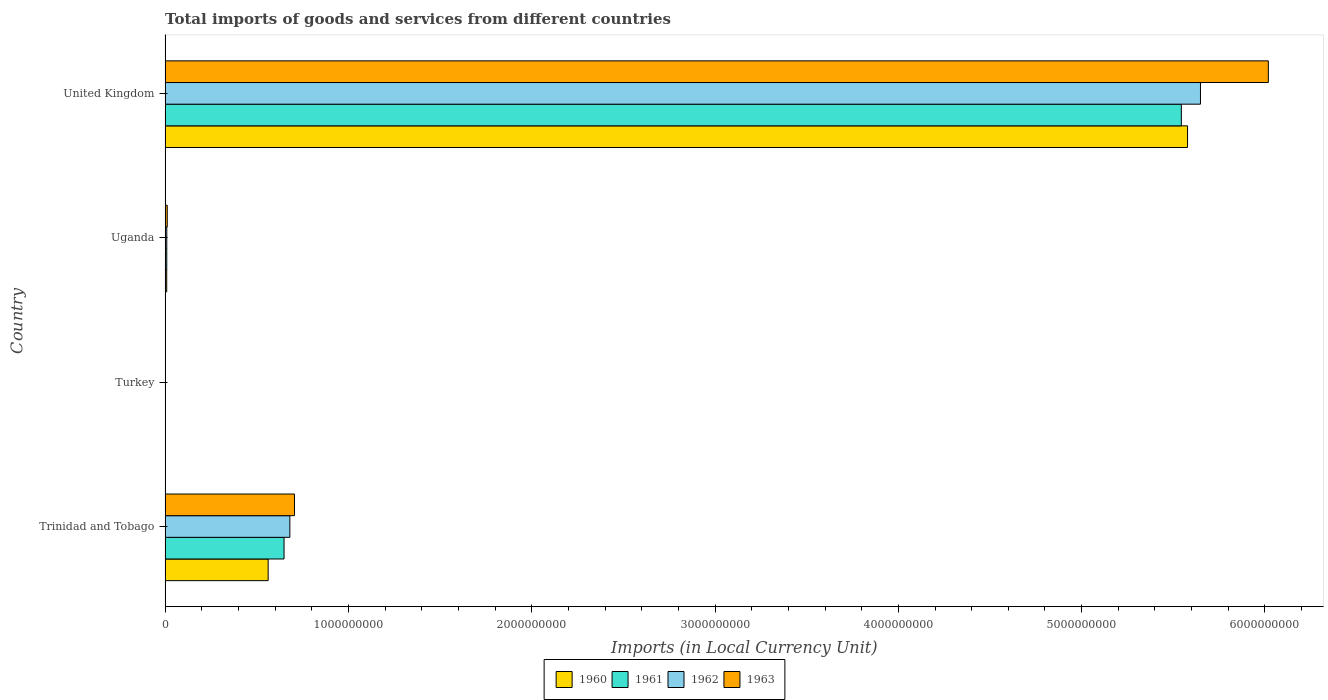How many different coloured bars are there?
Make the answer very short. 4. Are the number of bars per tick equal to the number of legend labels?
Give a very brief answer. Yes. Are the number of bars on each tick of the Y-axis equal?
Give a very brief answer. Yes. What is the label of the 2nd group of bars from the top?
Provide a short and direct response. Uganda. In how many cases, is the number of bars for a given country not equal to the number of legend labels?
Offer a very short reply. 0. What is the Amount of goods and services imports in 1962 in Trinidad and Tobago?
Your response must be concise. 6.81e+08. Across all countries, what is the maximum Amount of goods and services imports in 1960?
Your response must be concise. 5.58e+09. Across all countries, what is the minimum Amount of goods and services imports in 1962?
Offer a very short reply. 6400. In which country was the Amount of goods and services imports in 1961 maximum?
Your response must be concise. United Kingdom. In which country was the Amount of goods and services imports in 1963 minimum?
Make the answer very short. Turkey. What is the total Amount of goods and services imports in 1960 in the graph?
Provide a short and direct response. 6.15e+09. What is the difference between the Amount of goods and services imports in 1961 in Turkey and that in United Kingdom?
Your response must be concise. -5.54e+09. What is the difference between the Amount of goods and services imports in 1963 in Turkey and the Amount of goods and services imports in 1960 in Uganda?
Keep it short and to the point. -8.80e+06. What is the average Amount of goods and services imports in 1961 per country?
Your answer should be very brief. 1.55e+09. What is the difference between the Amount of goods and services imports in 1963 and Amount of goods and services imports in 1960 in Uganda?
Provide a short and direct response. 2.95e+06. In how many countries, is the Amount of goods and services imports in 1962 greater than 3600000000 LCU?
Your response must be concise. 1. What is the ratio of the Amount of goods and services imports in 1960 in Uganda to that in United Kingdom?
Offer a very short reply. 0. Is the Amount of goods and services imports in 1962 in Turkey less than that in United Kingdom?
Give a very brief answer. Yes. Is the difference between the Amount of goods and services imports in 1963 in Trinidad and Tobago and Turkey greater than the difference between the Amount of goods and services imports in 1960 in Trinidad and Tobago and Turkey?
Your answer should be very brief. Yes. What is the difference between the highest and the second highest Amount of goods and services imports in 1960?
Give a very brief answer. 5.02e+09. What is the difference between the highest and the lowest Amount of goods and services imports in 1962?
Give a very brief answer. 5.65e+09. In how many countries, is the Amount of goods and services imports in 1962 greater than the average Amount of goods and services imports in 1962 taken over all countries?
Provide a short and direct response. 1. Is the sum of the Amount of goods and services imports in 1963 in Trinidad and Tobago and Uganda greater than the maximum Amount of goods and services imports in 1962 across all countries?
Offer a terse response. No. What does the 4th bar from the top in Turkey represents?
Provide a succinct answer. 1960. Are all the bars in the graph horizontal?
Ensure brevity in your answer.  Yes. What is the difference between two consecutive major ticks on the X-axis?
Your response must be concise. 1.00e+09. Does the graph contain any zero values?
Provide a succinct answer. No. Does the graph contain grids?
Give a very brief answer. No. Where does the legend appear in the graph?
Ensure brevity in your answer.  Bottom center. How many legend labels are there?
Your answer should be very brief. 4. How are the legend labels stacked?
Offer a terse response. Horizontal. What is the title of the graph?
Your response must be concise. Total imports of goods and services from different countries. Does "1987" appear as one of the legend labels in the graph?
Give a very brief answer. No. What is the label or title of the X-axis?
Provide a short and direct response. Imports (in Local Currency Unit). What is the label or title of the Y-axis?
Provide a succinct answer. Country. What is the Imports (in Local Currency Unit) of 1960 in Trinidad and Tobago?
Your answer should be compact. 5.62e+08. What is the Imports (in Local Currency Unit) of 1961 in Trinidad and Tobago?
Ensure brevity in your answer.  6.49e+08. What is the Imports (in Local Currency Unit) of 1962 in Trinidad and Tobago?
Give a very brief answer. 6.81e+08. What is the Imports (in Local Currency Unit) of 1963 in Trinidad and Tobago?
Your answer should be very brief. 7.06e+08. What is the Imports (in Local Currency Unit) in 1960 in Turkey?
Provide a short and direct response. 2500. What is the Imports (in Local Currency Unit) in 1961 in Turkey?
Ensure brevity in your answer.  4900. What is the Imports (in Local Currency Unit) in 1962 in Turkey?
Your answer should be very brief. 6400. What is the Imports (in Local Currency Unit) of 1963 in Turkey?
Provide a succinct answer. 6500. What is the Imports (in Local Currency Unit) in 1960 in Uganda?
Offer a terse response. 8.80e+06. What is the Imports (in Local Currency Unit) in 1961 in Uganda?
Provide a succinct answer. 9.12e+06. What is the Imports (in Local Currency Unit) of 1962 in Uganda?
Keep it short and to the point. 9.19e+06. What is the Imports (in Local Currency Unit) in 1963 in Uganda?
Your answer should be very brief. 1.18e+07. What is the Imports (in Local Currency Unit) of 1960 in United Kingdom?
Offer a terse response. 5.58e+09. What is the Imports (in Local Currency Unit) in 1961 in United Kingdom?
Offer a terse response. 5.54e+09. What is the Imports (in Local Currency Unit) in 1962 in United Kingdom?
Your response must be concise. 5.65e+09. What is the Imports (in Local Currency Unit) of 1963 in United Kingdom?
Offer a very short reply. 6.02e+09. Across all countries, what is the maximum Imports (in Local Currency Unit) of 1960?
Give a very brief answer. 5.58e+09. Across all countries, what is the maximum Imports (in Local Currency Unit) in 1961?
Offer a very short reply. 5.54e+09. Across all countries, what is the maximum Imports (in Local Currency Unit) in 1962?
Ensure brevity in your answer.  5.65e+09. Across all countries, what is the maximum Imports (in Local Currency Unit) of 1963?
Offer a terse response. 6.02e+09. Across all countries, what is the minimum Imports (in Local Currency Unit) of 1960?
Your response must be concise. 2500. Across all countries, what is the minimum Imports (in Local Currency Unit) in 1961?
Your answer should be compact. 4900. Across all countries, what is the minimum Imports (in Local Currency Unit) of 1962?
Give a very brief answer. 6400. Across all countries, what is the minimum Imports (in Local Currency Unit) of 1963?
Make the answer very short. 6500. What is the total Imports (in Local Currency Unit) of 1960 in the graph?
Ensure brevity in your answer.  6.15e+09. What is the total Imports (in Local Currency Unit) in 1961 in the graph?
Your response must be concise. 6.20e+09. What is the total Imports (in Local Currency Unit) of 1962 in the graph?
Your answer should be very brief. 6.34e+09. What is the total Imports (in Local Currency Unit) in 1963 in the graph?
Offer a very short reply. 6.74e+09. What is the difference between the Imports (in Local Currency Unit) of 1960 in Trinidad and Tobago and that in Turkey?
Your answer should be very brief. 5.62e+08. What is the difference between the Imports (in Local Currency Unit) in 1961 in Trinidad and Tobago and that in Turkey?
Keep it short and to the point. 6.49e+08. What is the difference between the Imports (in Local Currency Unit) of 1962 in Trinidad and Tobago and that in Turkey?
Your answer should be very brief. 6.81e+08. What is the difference between the Imports (in Local Currency Unit) in 1963 in Trinidad and Tobago and that in Turkey?
Your answer should be compact. 7.06e+08. What is the difference between the Imports (in Local Currency Unit) of 1960 in Trinidad and Tobago and that in Uganda?
Provide a succinct answer. 5.53e+08. What is the difference between the Imports (in Local Currency Unit) of 1961 in Trinidad and Tobago and that in Uganda?
Make the answer very short. 6.40e+08. What is the difference between the Imports (in Local Currency Unit) of 1962 in Trinidad and Tobago and that in Uganda?
Your answer should be very brief. 6.71e+08. What is the difference between the Imports (in Local Currency Unit) of 1963 in Trinidad and Tobago and that in Uganda?
Provide a short and direct response. 6.94e+08. What is the difference between the Imports (in Local Currency Unit) of 1960 in Trinidad and Tobago and that in United Kingdom?
Your answer should be very brief. -5.02e+09. What is the difference between the Imports (in Local Currency Unit) of 1961 in Trinidad and Tobago and that in United Kingdom?
Your response must be concise. -4.89e+09. What is the difference between the Imports (in Local Currency Unit) in 1962 in Trinidad and Tobago and that in United Kingdom?
Provide a short and direct response. -4.97e+09. What is the difference between the Imports (in Local Currency Unit) of 1963 in Trinidad and Tobago and that in United Kingdom?
Offer a terse response. -5.31e+09. What is the difference between the Imports (in Local Currency Unit) in 1960 in Turkey and that in Uganda?
Ensure brevity in your answer.  -8.80e+06. What is the difference between the Imports (in Local Currency Unit) in 1961 in Turkey and that in Uganda?
Your answer should be very brief. -9.11e+06. What is the difference between the Imports (in Local Currency Unit) in 1962 in Turkey and that in Uganda?
Keep it short and to the point. -9.18e+06. What is the difference between the Imports (in Local Currency Unit) in 1963 in Turkey and that in Uganda?
Offer a terse response. -1.18e+07. What is the difference between the Imports (in Local Currency Unit) of 1960 in Turkey and that in United Kingdom?
Offer a very short reply. -5.58e+09. What is the difference between the Imports (in Local Currency Unit) of 1961 in Turkey and that in United Kingdom?
Make the answer very short. -5.54e+09. What is the difference between the Imports (in Local Currency Unit) of 1962 in Turkey and that in United Kingdom?
Provide a short and direct response. -5.65e+09. What is the difference between the Imports (in Local Currency Unit) of 1963 in Turkey and that in United Kingdom?
Ensure brevity in your answer.  -6.02e+09. What is the difference between the Imports (in Local Currency Unit) in 1960 in Uganda and that in United Kingdom?
Offer a terse response. -5.57e+09. What is the difference between the Imports (in Local Currency Unit) in 1961 in Uganda and that in United Kingdom?
Ensure brevity in your answer.  -5.53e+09. What is the difference between the Imports (in Local Currency Unit) in 1962 in Uganda and that in United Kingdom?
Make the answer very short. -5.64e+09. What is the difference between the Imports (in Local Currency Unit) in 1963 in Uganda and that in United Kingdom?
Your response must be concise. -6.01e+09. What is the difference between the Imports (in Local Currency Unit) in 1960 in Trinidad and Tobago and the Imports (in Local Currency Unit) in 1961 in Turkey?
Make the answer very short. 5.62e+08. What is the difference between the Imports (in Local Currency Unit) in 1960 in Trinidad and Tobago and the Imports (in Local Currency Unit) in 1962 in Turkey?
Keep it short and to the point. 5.62e+08. What is the difference between the Imports (in Local Currency Unit) of 1960 in Trinidad and Tobago and the Imports (in Local Currency Unit) of 1963 in Turkey?
Your answer should be very brief. 5.62e+08. What is the difference between the Imports (in Local Currency Unit) of 1961 in Trinidad and Tobago and the Imports (in Local Currency Unit) of 1962 in Turkey?
Offer a very short reply. 6.49e+08. What is the difference between the Imports (in Local Currency Unit) in 1961 in Trinidad and Tobago and the Imports (in Local Currency Unit) in 1963 in Turkey?
Your answer should be very brief. 6.49e+08. What is the difference between the Imports (in Local Currency Unit) in 1962 in Trinidad and Tobago and the Imports (in Local Currency Unit) in 1963 in Turkey?
Ensure brevity in your answer.  6.81e+08. What is the difference between the Imports (in Local Currency Unit) in 1960 in Trinidad and Tobago and the Imports (in Local Currency Unit) in 1961 in Uganda?
Offer a terse response. 5.53e+08. What is the difference between the Imports (in Local Currency Unit) of 1960 in Trinidad and Tobago and the Imports (in Local Currency Unit) of 1962 in Uganda?
Your answer should be compact. 5.53e+08. What is the difference between the Imports (in Local Currency Unit) in 1960 in Trinidad and Tobago and the Imports (in Local Currency Unit) in 1963 in Uganda?
Provide a succinct answer. 5.50e+08. What is the difference between the Imports (in Local Currency Unit) of 1961 in Trinidad and Tobago and the Imports (in Local Currency Unit) of 1962 in Uganda?
Provide a succinct answer. 6.40e+08. What is the difference between the Imports (in Local Currency Unit) of 1961 in Trinidad and Tobago and the Imports (in Local Currency Unit) of 1963 in Uganda?
Offer a very short reply. 6.37e+08. What is the difference between the Imports (in Local Currency Unit) in 1962 in Trinidad and Tobago and the Imports (in Local Currency Unit) in 1963 in Uganda?
Offer a terse response. 6.69e+08. What is the difference between the Imports (in Local Currency Unit) in 1960 in Trinidad and Tobago and the Imports (in Local Currency Unit) in 1961 in United Kingdom?
Offer a terse response. -4.98e+09. What is the difference between the Imports (in Local Currency Unit) of 1960 in Trinidad and Tobago and the Imports (in Local Currency Unit) of 1962 in United Kingdom?
Your answer should be compact. -5.09e+09. What is the difference between the Imports (in Local Currency Unit) of 1960 in Trinidad and Tobago and the Imports (in Local Currency Unit) of 1963 in United Kingdom?
Make the answer very short. -5.46e+09. What is the difference between the Imports (in Local Currency Unit) in 1961 in Trinidad and Tobago and the Imports (in Local Currency Unit) in 1962 in United Kingdom?
Keep it short and to the point. -5.00e+09. What is the difference between the Imports (in Local Currency Unit) in 1961 in Trinidad and Tobago and the Imports (in Local Currency Unit) in 1963 in United Kingdom?
Your answer should be very brief. -5.37e+09. What is the difference between the Imports (in Local Currency Unit) in 1962 in Trinidad and Tobago and the Imports (in Local Currency Unit) in 1963 in United Kingdom?
Offer a terse response. -5.34e+09. What is the difference between the Imports (in Local Currency Unit) in 1960 in Turkey and the Imports (in Local Currency Unit) in 1961 in Uganda?
Your answer should be very brief. -9.11e+06. What is the difference between the Imports (in Local Currency Unit) of 1960 in Turkey and the Imports (in Local Currency Unit) of 1962 in Uganda?
Keep it short and to the point. -9.18e+06. What is the difference between the Imports (in Local Currency Unit) of 1960 in Turkey and the Imports (in Local Currency Unit) of 1963 in Uganda?
Provide a short and direct response. -1.18e+07. What is the difference between the Imports (in Local Currency Unit) of 1961 in Turkey and the Imports (in Local Currency Unit) of 1962 in Uganda?
Your response must be concise. -9.18e+06. What is the difference between the Imports (in Local Currency Unit) in 1961 in Turkey and the Imports (in Local Currency Unit) in 1963 in Uganda?
Provide a succinct answer. -1.18e+07. What is the difference between the Imports (in Local Currency Unit) in 1962 in Turkey and the Imports (in Local Currency Unit) in 1963 in Uganda?
Keep it short and to the point. -1.18e+07. What is the difference between the Imports (in Local Currency Unit) of 1960 in Turkey and the Imports (in Local Currency Unit) of 1961 in United Kingdom?
Give a very brief answer. -5.54e+09. What is the difference between the Imports (in Local Currency Unit) of 1960 in Turkey and the Imports (in Local Currency Unit) of 1962 in United Kingdom?
Your answer should be compact. -5.65e+09. What is the difference between the Imports (in Local Currency Unit) of 1960 in Turkey and the Imports (in Local Currency Unit) of 1963 in United Kingdom?
Provide a succinct answer. -6.02e+09. What is the difference between the Imports (in Local Currency Unit) of 1961 in Turkey and the Imports (in Local Currency Unit) of 1962 in United Kingdom?
Ensure brevity in your answer.  -5.65e+09. What is the difference between the Imports (in Local Currency Unit) in 1961 in Turkey and the Imports (in Local Currency Unit) in 1963 in United Kingdom?
Your answer should be very brief. -6.02e+09. What is the difference between the Imports (in Local Currency Unit) in 1962 in Turkey and the Imports (in Local Currency Unit) in 1963 in United Kingdom?
Keep it short and to the point. -6.02e+09. What is the difference between the Imports (in Local Currency Unit) of 1960 in Uganda and the Imports (in Local Currency Unit) of 1961 in United Kingdom?
Ensure brevity in your answer.  -5.54e+09. What is the difference between the Imports (in Local Currency Unit) in 1960 in Uganda and the Imports (in Local Currency Unit) in 1962 in United Kingdom?
Ensure brevity in your answer.  -5.64e+09. What is the difference between the Imports (in Local Currency Unit) of 1960 in Uganda and the Imports (in Local Currency Unit) of 1963 in United Kingdom?
Give a very brief answer. -6.01e+09. What is the difference between the Imports (in Local Currency Unit) of 1961 in Uganda and the Imports (in Local Currency Unit) of 1962 in United Kingdom?
Provide a succinct answer. -5.64e+09. What is the difference between the Imports (in Local Currency Unit) in 1961 in Uganda and the Imports (in Local Currency Unit) in 1963 in United Kingdom?
Make the answer very short. -6.01e+09. What is the difference between the Imports (in Local Currency Unit) in 1962 in Uganda and the Imports (in Local Currency Unit) in 1963 in United Kingdom?
Ensure brevity in your answer.  -6.01e+09. What is the average Imports (in Local Currency Unit) in 1960 per country?
Give a very brief answer. 1.54e+09. What is the average Imports (in Local Currency Unit) of 1961 per country?
Provide a short and direct response. 1.55e+09. What is the average Imports (in Local Currency Unit) of 1962 per country?
Keep it short and to the point. 1.58e+09. What is the average Imports (in Local Currency Unit) of 1963 per country?
Ensure brevity in your answer.  1.68e+09. What is the difference between the Imports (in Local Currency Unit) of 1960 and Imports (in Local Currency Unit) of 1961 in Trinidad and Tobago?
Your response must be concise. -8.67e+07. What is the difference between the Imports (in Local Currency Unit) in 1960 and Imports (in Local Currency Unit) in 1962 in Trinidad and Tobago?
Give a very brief answer. -1.18e+08. What is the difference between the Imports (in Local Currency Unit) in 1960 and Imports (in Local Currency Unit) in 1963 in Trinidad and Tobago?
Give a very brief answer. -1.44e+08. What is the difference between the Imports (in Local Currency Unit) in 1961 and Imports (in Local Currency Unit) in 1962 in Trinidad and Tobago?
Make the answer very short. -3.17e+07. What is the difference between the Imports (in Local Currency Unit) in 1961 and Imports (in Local Currency Unit) in 1963 in Trinidad and Tobago?
Offer a terse response. -5.69e+07. What is the difference between the Imports (in Local Currency Unit) in 1962 and Imports (in Local Currency Unit) in 1963 in Trinidad and Tobago?
Ensure brevity in your answer.  -2.52e+07. What is the difference between the Imports (in Local Currency Unit) of 1960 and Imports (in Local Currency Unit) of 1961 in Turkey?
Provide a succinct answer. -2400. What is the difference between the Imports (in Local Currency Unit) in 1960 and Imports (in Local Currency Unit) in 1962 in Turkey?
Your response must be concise. -3900. What is the difference between the Imports (in Local Currency Unit) in 1960 and Imports (in Local Currency Unit) in 1963 in Turkey?
Ensure brevity in your answer.  -4000. What is the difference between the Imports (in Local Currency Unit) of 1961 and Imports (in Local Currency Unit) of 1962 in Turkey?
Give a very brief answer. -1500. What is the difference between the Imports (in Local Currency Unit) of 1961 and Imports (in Local Currency Unit) of 1963 in Turkey?
Your answer should be very brief. -1600. What is the difference between the Imports (in Local Currency Unit) of 1962 and Imports (in Local Currency Unit) of 1963 in Turkey?
Your response must be concise. -100. What is the difference between the Imports (in Local Currency Unit) of 1960 and Imports (in Local Currency Unit) of 1961 in Uganda?
Give a very brief answer. -3.13e+05. What is the difference between the Imports (in Local Currency Unit) in 1960 and Imports (in Local Currency Unit) in 1962 in Uganda?
Provide a succinct answer. -3.83e+05. What is the difference between the Imports (in Local Currency Unit) in 1960 and Imports (in Local Currency Unit) in 1963 in Uganda?
Offer a terse response. -2.95e+06. What is the difference between the Imports (in Local Currency Unit) in 1961 and Imports (in Local Currency Unit) in 1962 in Uganda?
Provide a succinct answer. -7.06e+04. What is the difference between the Imports (in Local Currency Unit) of 1961 and Imports (in Local Currency Unit) of 1963 in Uganda?
Provide a succinct answer. -2.64e+06. What is the difference between the Imports (in Local Currency Unit) in 1962 and Imports (in Local Currency Unit) in 1963 in Uganda?
Make the answer very short. -2.57e+06. What is the difference between the Imports (in Local Currency Unit) of 1960 and Imports (in Local Currency Unit) of 1961 in United Kingdom?
Your answer should be compact. 3.38e+07. What is the difference between the Imports (in Local Currency Unit) in 1960 and Imports (in Local Currency Unit) in 1962 in United Kingdom?
Your response must be concise. -7.06e+07. What is the difference between the Imports (in Local Currency Unit) of 1960 and Imports (in Local Currency Unit) of 1963 in United Kingdom?
Keep it short and to the point. -4.41e+08. What is the difference between the Imports (in Local Currency Unit) in 1961 and Imports (in Local Currency Unit) in 1962 in United Kingdom?
Offer a very short reply. -1.04e+08. What is the difference between the Imports (in Local Currency Unit) in 1961 and Imports (in Local Currency Unit) in 1963 in United Kingdom?
Your response must be concise. -4.75e+08. What is the difference between the Imports (in Local Currency Unit) in 1962 and Imports (in Local Currency Unit) in 1963 in United Kingdom?
Offer a terse response. -3.70e+08. What is the ratio of the Imports (in Local Currency Unit) of 1960 in Trinidad and Tobago to that in Turkey?
Give a very brief answer. 2.25e+05. What is the ratio of the Imports (in Local Currency Unit) of 1961 in Trinidad and Tobago to that in Turkey?
Your answer should be compact. 1.32e+05. What is the ratio of the Imports (in Local Currency Unit) of 1962 in Trinidad and Tobago to that in Turkey?
Ensure brevity in your answer.  1.06e+05. What is the ratio of the Imports (in Local Currency Unit) of 1963 in Trinidad and Tobago to that in Turkey?
Your response must be concise. 1.09e+05. What is the ratio of the Imports (in Local Currency Unit) in 1960 in Trinidad and Tobago to that in Uganda?
Your response must be concise. 63.86. What is the ratio of the Imports (in Local Currency Unit) in 1961 in Trinidad and Tobago to that in Uganda?
Your answer should be very brief. 71.18. What is the ratio of the Imports (in Local Currency Unit) in 1962 in Trinidad and Tobago to that in Uganda?
Your answer should be very brief. 74.08. What is the ratio of the Imports (in Local Currency Unit) in 1963 in Trinidad and Tobago to that in Uganda?
Ensure brevity in your answer.  60.02. What is the ratio of the Imports (in Local Currency Unit) in 1960 in Trinidad and Tobago to that in United Kingdom?
Offer a very short reply. 0.1. What is the ratio of the Imports (in Local Currency Unit) in 1961 in Trinidad and Tobago to that in United Kingdom?
Keep it short and to the point. 0.12. What is the ratio of the Imports (in Local Currency Unit) in 1962 in Trinidad and Tobago to that in United Kingdom?
Keep it short and to the point. 0.12. What is the ratio of the Imports (in Local Currency Unit) of 1963 in Trinidad and Tobago to that in United Kingdom?
Keep it short and to the point. 0.12. What is the ratio of the Imports (in Local Currency Unit) in 1960 in Turkey to that in Uganda?
Ensure brevity in your answer.  0. What is the ratio of the Imports (in Local Currency Unit) in 1962 in Turkey to that in Uganda?
Your answer should be very brief. 0. What is the ratio of the Imports (in Local Currency Unit) in 1963 in Turkey to that in Uganda?
Your answer should be compact. 0. What is the ratio of the Imports (in Local Currency Unit) in 1962 in Turkey to that in United Kingdom?
Your answer should be very brief. 0. What is the ratio of the Imports (in Local Currency Unit) in 1963 in Turkey to that in United Kingdom?
Offer a terse response. 0. What is the ratio of the Imports (in Local Currency Unit) of 1960 in Uganda to that in United Kingdom?
Your answer should be compact. 0. What is the ratio of the Imports (in Local Currency Unit) in 1961 in Uganda to that in United Kingdom?
Make the answer very short. 0. What is the ratio of the Imports (in Local Currency Unit) of 1962 in Uganda to that in United Kingdom?
Provide a short and direct response. 0. What is the ratio of the Imports (in Local Currency Unit) in 1963 in Uganda to that in United Kingdom?
Your answer should be compact. 0. What is the difference between the highest and the second highest Imports (in Local Currency Unit) of 1960?
Your response must be concise. 5.02e+09. What is the difference between the highest and the second highest Imports (in Local Currency Unit) of 1961?
Ensure brevity in your answer.  4.89e+09. What is the difference between the highest and the second highest Imports (in Local Currency Unit) of 1962?
Provide a short and direct response. 4.97e+09. What is the difference between the highest and the second highest Imports (in Local Currency Unit) in 1963?
Provide a short and direct response. 5.31e+09. What is the difference between the highest and the lowest Imports (in Local Currency Unit) of 1960?
Give a very brief answer. 5.58e+09. What is the difference between the highest and the lowest Imports (in Local Currency Unit) of 1961?
Provide a short and direct response. 5.54e+09. What is the difference between the highest and the lowest Imports (in Local Currency Unit) in 1962?
Keep it short and to the point. 5.65e+09. What is the difference between the highest and the lowest Imports (in Local Currency Unit) in 1963?
Provide a succinct answer. 6.02e+09. 